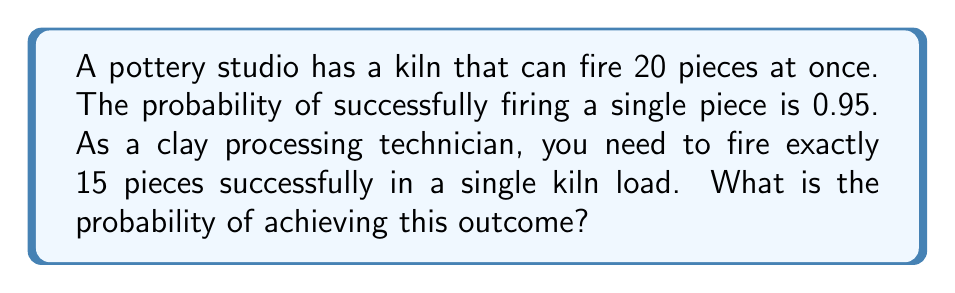Give your solution to this math problem. To solve this problem, we can use the binomial probability formula:

$$ P(X = k) = \binom{n}{k} p^k (1-p)^{n-k} $$

Where:
- $n$ is the total number of trials (pieces in the kiln)
- $k$ is the number of successes (successfully fired pieces)
- $p$ is the probability of success for a single trial

Given:
- $n = 20$ (total pieces in the kiln)
- $k = 15$ (desired number of successfully fired pieces)
- $p = 0.95$ (probability of successfully firing a single piece)

Step 1: Calculate the binomial coefficient
$$ \binom{20}{15} = \frac{20!}{15!(20-15)!} = \frac{20!}{15!5!} = 15504 $$

Step 2: Calculate $p^k$
$$ 0.95^{15} \approx 0.4633 $$

Step 3: Calculate $(1-p)^{n-k}$
$$ (1-0.95)^{20-15} = 0.05^5 \approx 3.125 \times 10^{-7} $$

Step 4: Multiply all parts together
$$ P(X = 15) = 15504 \times 0.4633 \times (3.125 \times 10^{-7}) \approx 0.0022 $$

Therefore, the probability of successfully firing exactly 15 pieces out of 20 in a single kiln load is approximately 0.0022 or 0.22%.
Answer: 0.0022 